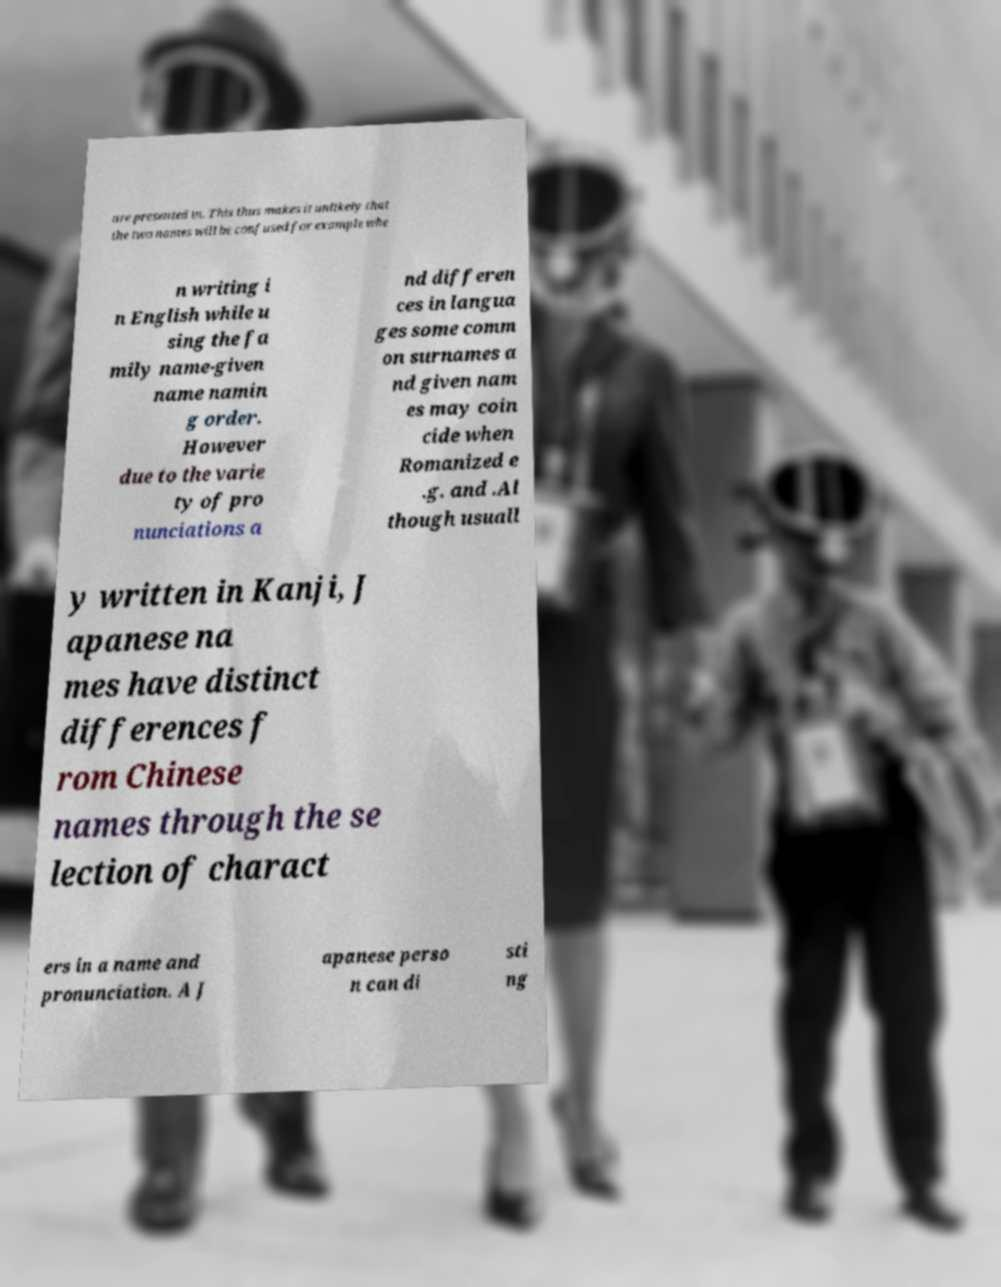Could you extract and type out the text from this image? are presented in. This thus makes it unlikely that the two names will be confused for example whe n writing i n English while u sing the fa mily name-given name namin g order. However due to the varie ty of pro nunciations a nd differen ces in langua ges some comm on surnames a nd given nam es may coin cide when Romanized e .g. and .Al though usuall y written in Kanji, J apanese na mes have distinct differences f rom Chinese names through the se lection of charact ers in a name and pronunciation. A J apanese perso n can di sti ng 